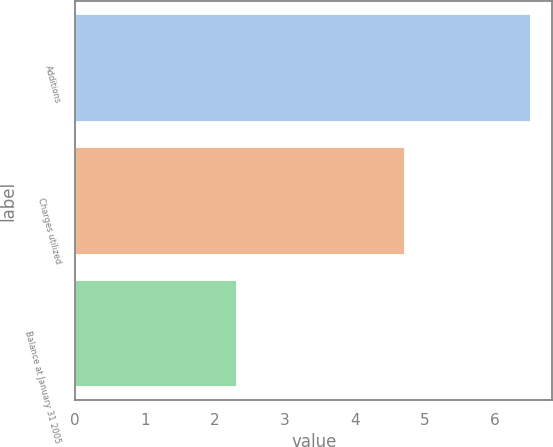Convert chart. <chart><loc_0><loc_0><loc_500><loc_500><bar_chart><fcel>Additions<fcel>Charges utilized<fcel>Balance at January 31 2005<nl><fcel>6.5<fcel>4.7<fcel>2.3<nl></chart> 